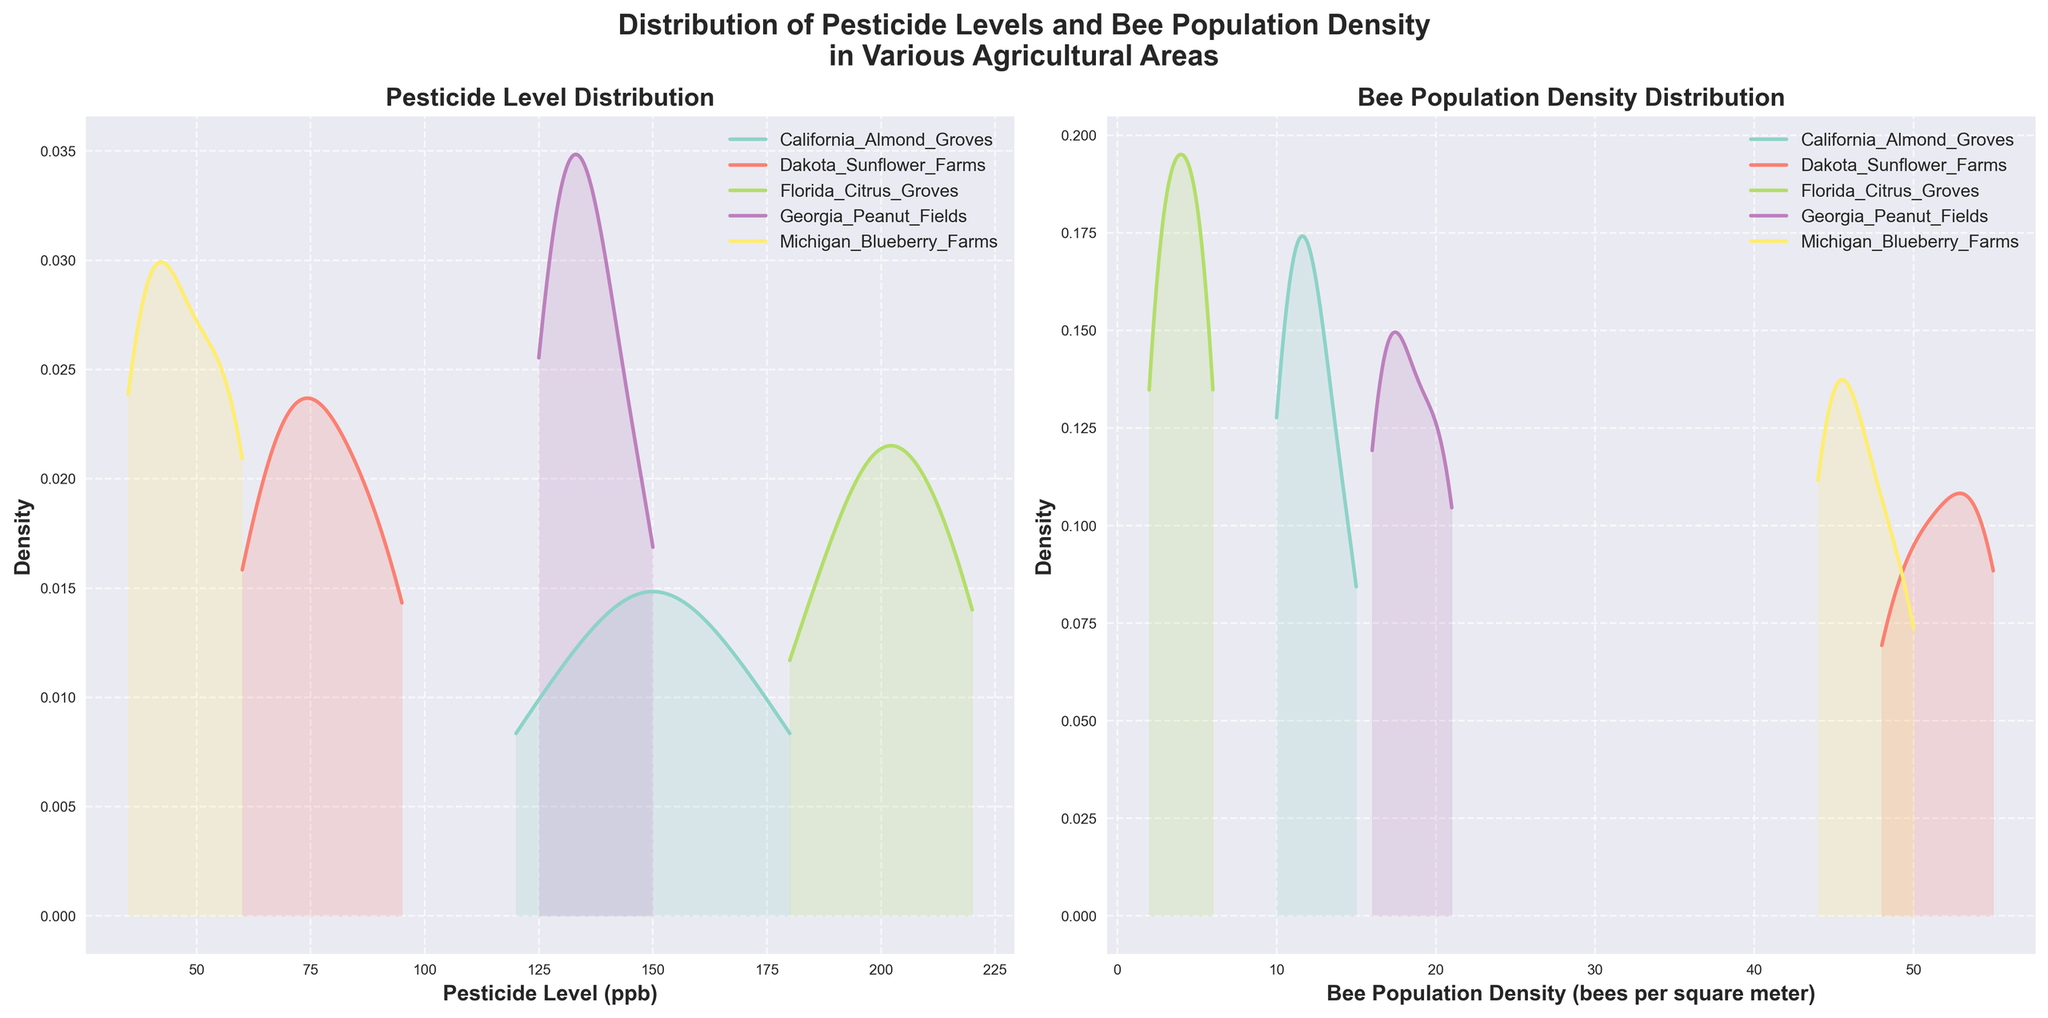What is the title of the figure? The title is easily found at the top of the figure and reads "Distribution of Pesticide Levels and Bee Population Density in Various Agricultural Areas".
Answer: Distribution of Pesticide Levels and Bee Population Density in Various Agricultural Areas Which agricultural area has the highest peak in pesticide level density? The peak in pesticide level density for each area can be visually identified by the highest point on the density plot on the left subplot. Florida Citrus Groves show the highest peak.
Answer: Florida Citrus Groves Which area has the widest range of bee population density? By observing the width of the density curves in the right subplot, Michigan Blueberry Farms has the widest range since its curve spans from around 44 to 50 bpsm.
Answer: Michigan Blueberry Farms What is the general relationship between pesticide levels and bee population density for each area? By comparing the peak positions in both subplots, areas with higher pesticide levels (e.g., Florida Citrus Groves) tend to have lower bee population densities, while areas with lower pesticide levels (e.g., Dakota Sunflower Farms) have higher bee population densities.
Answer: Inverse relationship Which agricultural area has the highest density of bee population? The highest peak in the bee population density subplot on the right side indicates the area with the highest density, which is Dakota Sunflower Farms.
Answer: Dakota Sunflower Farms 